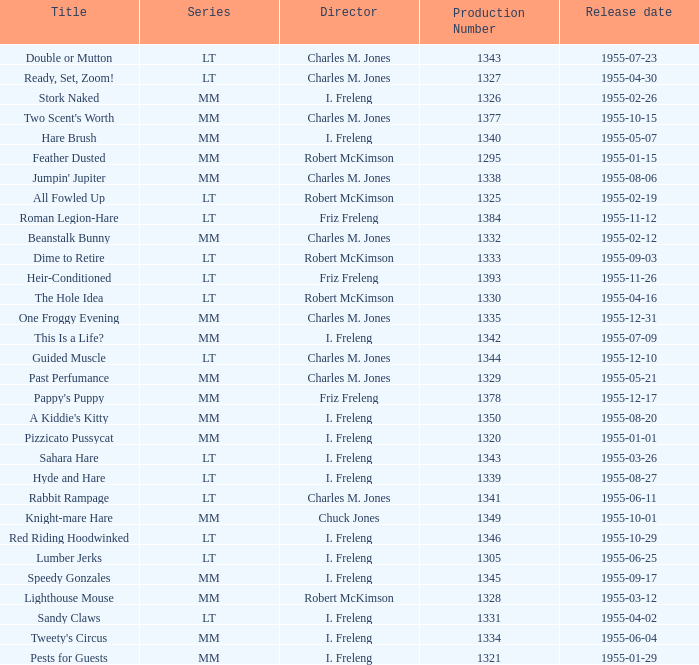What is the release date of production number 1327? 1955-04-30. 